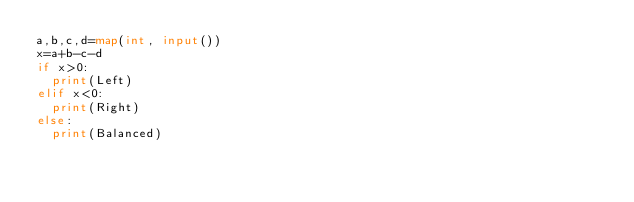<code> <loc_0><loc_0><loc_500><loc_500><_Python_>a,b,c,d=map(int, input())
x=a+b-c-d
if x>0:
  print(Left)
elif x<0:
  print(Right)
else:
  print(Balanced)</code> 